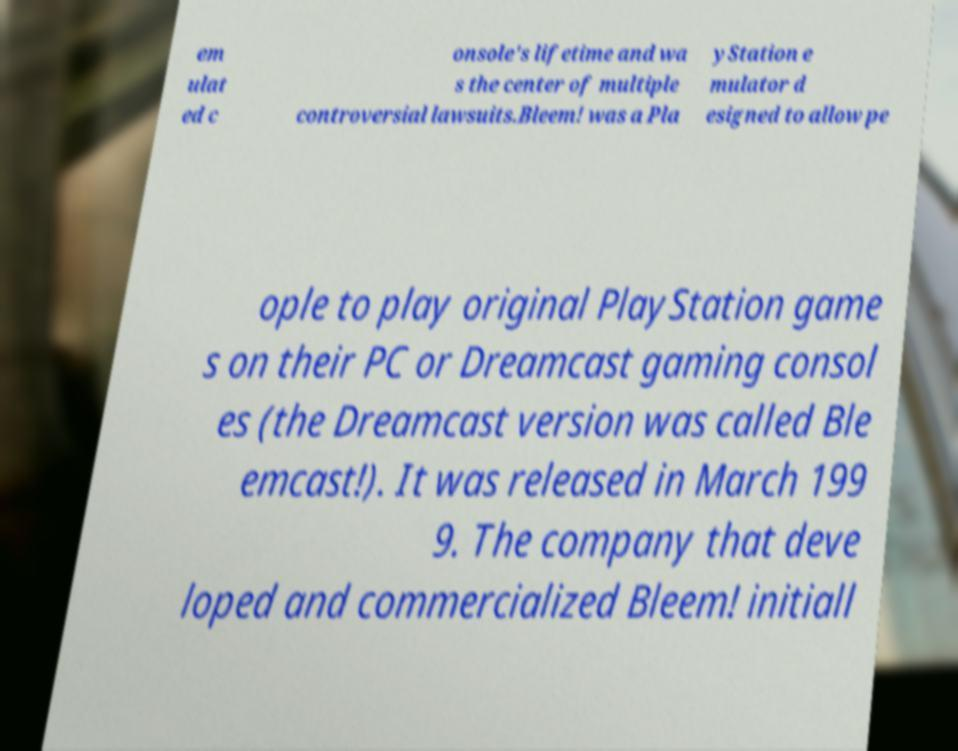Can you accurately transcribe the text from the provided image for me? em ulat ed c onsole's lifetime and wa s the center of multiple controversial lawsuits.Bleem! was a Pla yStation e mulator d esigned to allow pe ople to play original PlayStation game s on their PC or Dreamcast gaming consol es (the Dreamcast version was called Ble emcast!). It was released in March 199 9. The company that deve loped and commercialized Bleem! initiall 